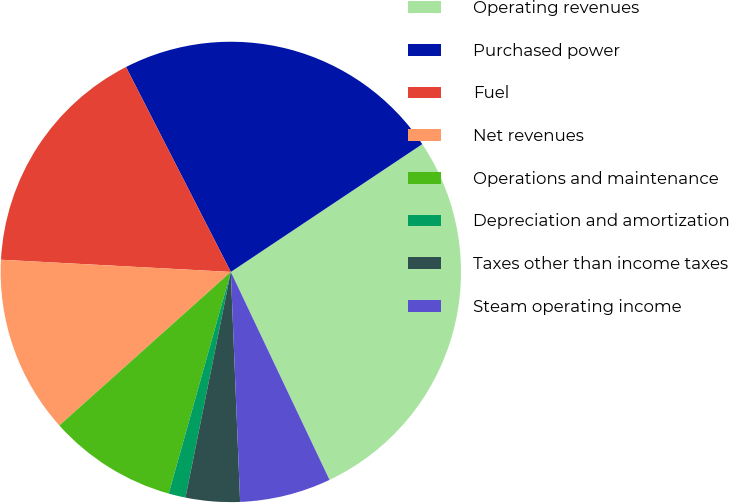<chart> <loc_0><loc_0><loc_500><loc_500><pie_chart><fcel>Operating revenues<fcel>Purchased power<fcel>Fuel<fcel>Net revenues<fcel>Operations and maintenance<fcel>Depreciation and amortization<fcel>Taxes other than income taxes<fcel>Steam operating income<nl><fcel>27.32%<fcel>23.16%<fcel>16.63%<fcel>12.47%<fcel>9.03%<fcel>1.19%<fcel>3.8%<fcel>6.41%<nl></chart> 